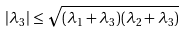<formula> <loc_0><loc_0><loc_500><loc_500>| \lambda _ { 3 } | \leq \sqrt { ( \lambda _ { 1 } + \lambda _ { 3 } ) ( \lambda _ { 2 } + \lambda _ { 3 } ) }</formula> 